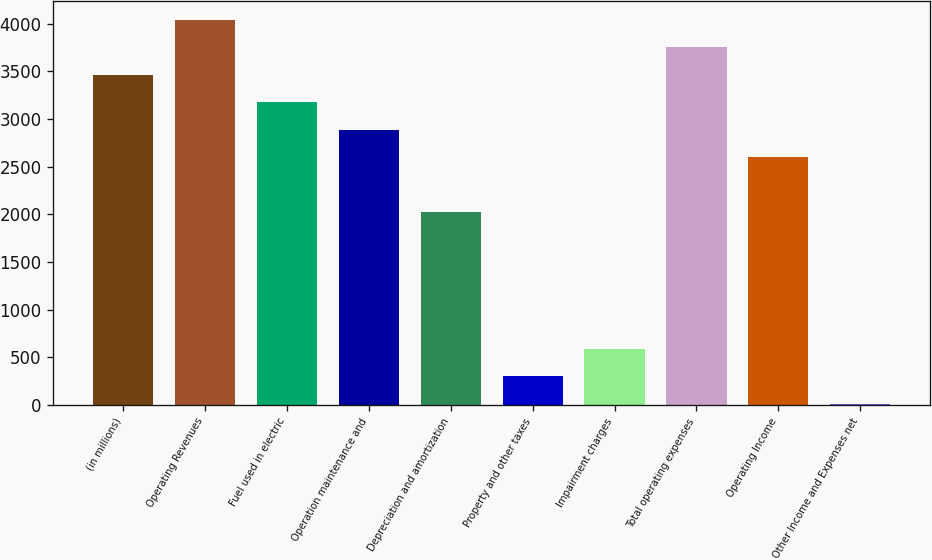Convert chart. <chart><loc_0><loc_0><loc_500><loc_500><bar_chart><fcel>(in millions)<fcel>Operating Revenues<fcel>Fuel used in electric<fcel>Operation maintenance and<fcel>Depreciation and amortization<fcel>Property and other taxes<fcel>Impairment charges<fcel>Total operating expenses<fcel>Operating Income<fcel>Other Income and Expenses net<nl><fcel>3465.8<fcel>4041.6<fcel>3177.9<fcel>2890<fcel>2026.3<fcel>298.9<fcel>586.8<fcel>3753.7<fcel>2602.1<fcel>11<nl></chart> 